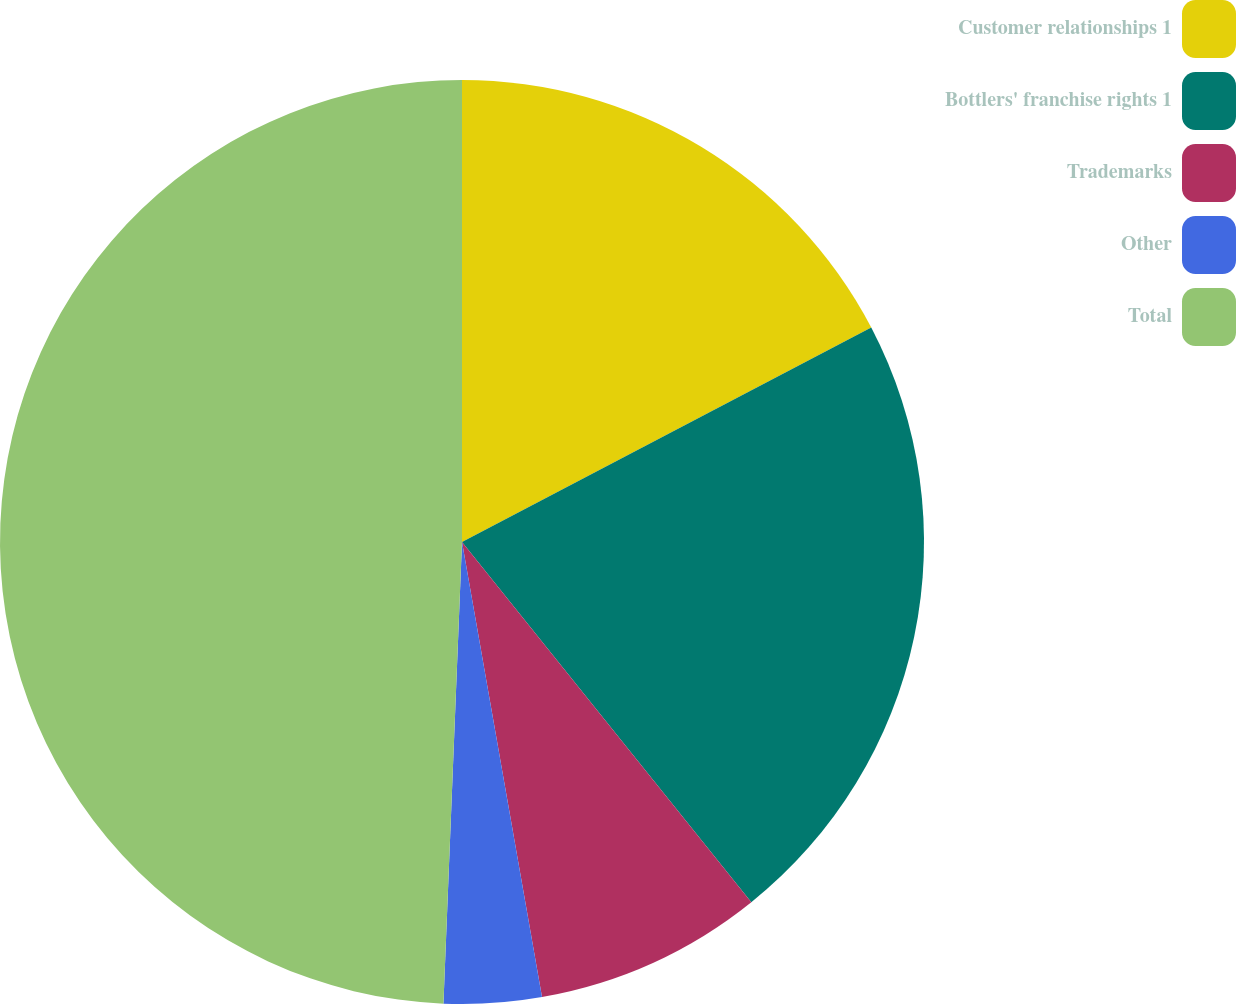<chart> <loc_0><loc_0><loc_500><loc_500><pie_chart><fcel>Customer relationships 1<fcel>Bottlers' franchise rights 1<fcel>Trademarks<fcel>Other<fcel>Total<nl><fcel>17.32%<fcel>21.91%<fcel>8.0%<fcel>3.41%<fcel>49.36%<nl></chart> 